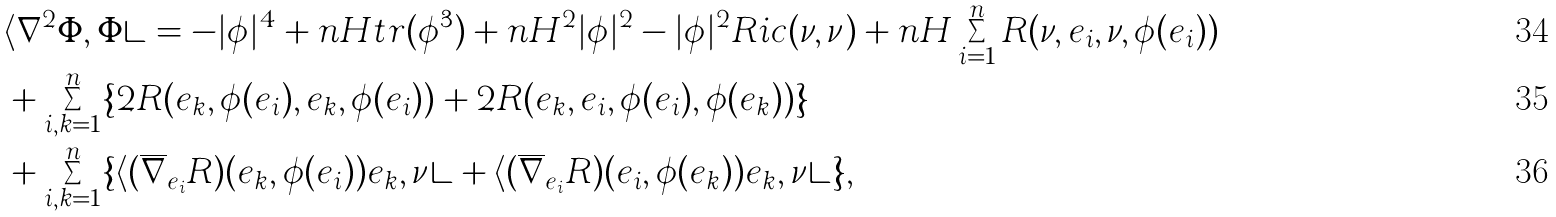<formula> <loc_0><loc_0><loc_500><loc_500>& \langle \nabla ^ { 2 } \Phi , \Phi \rangle = - | \phi | ^ { 4 } + n H t r ( \phi ^ { 3 } ) + n H ^ { 2 } | \phi | ^ { 2 } - | \phi | ^ { 2 } R i c ( \nu , \nu ) + n H \sum _ { i = 1 } ^ { n } R ( \nu , e _ { i } , \nu , \phi ( e _ { i } ) ) \\ & + \sum _ { i , k = 1 } ^ { n } \{ 2 R ( e _ { k } , \phi ( e _ { i } ) , e _ { k } , \phi ( e _ { i } ) ) + 2 R ( e _ { k } , e _ { i } , \phi ( e _ { i } ) , \phi ( e _ { k } ) ) \} \\ & + \sum _ { i , k = 1 } ^ { n } \{ \langle ( \overline { \nabla } _ { e _ { i } } R ) ( e _ { k } , \phi ( e _ { i } ) ) e _ { k } , \nu \rangle + \langle ( \overline { \nabla } _ { e _ { i } } R ) ( e _ { i } , \phi ( e _ { k } ) ) e _ { k } , \nu \rangle \} ,</formula> 